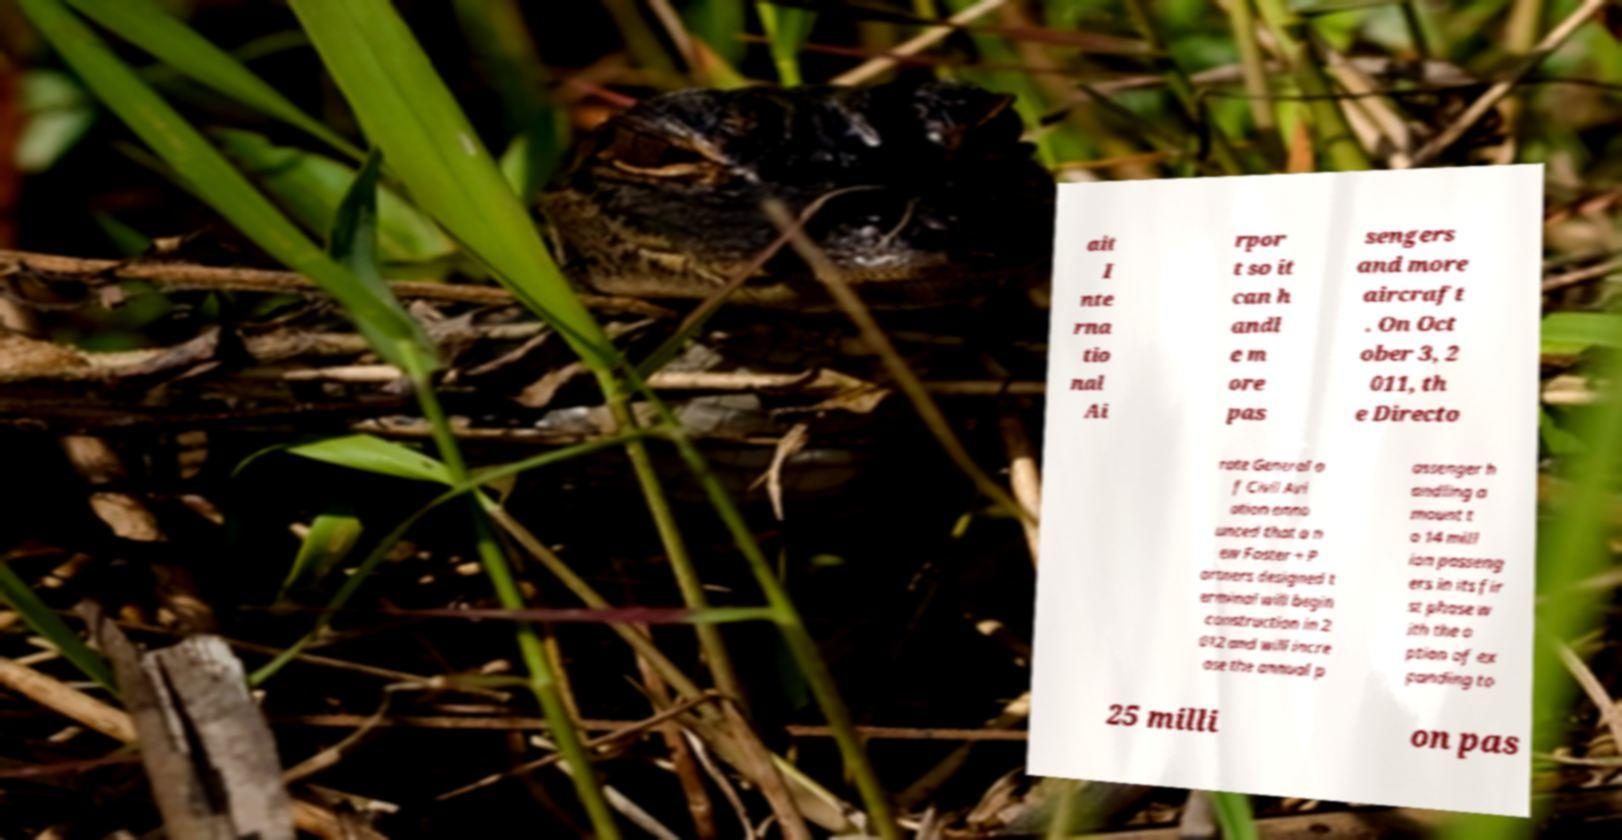Can you accurately transcribe the text from the provided image for me? ait I nte rna tio nal Ai rpor t so it can h andl e m ore pas sengers and more aircraft . On Oct ober 3, 2 011, th e Directo rate General o f Civil Avi ation anno unced that a n ew Foster + P artners designed t erminal will begin construction in 2 012 and will incre ase the annual p assenger h andling a mount t o 14 mill ion passeng ers in its fir st phase w ith the o ption of ex panding to 25 milli on pas 